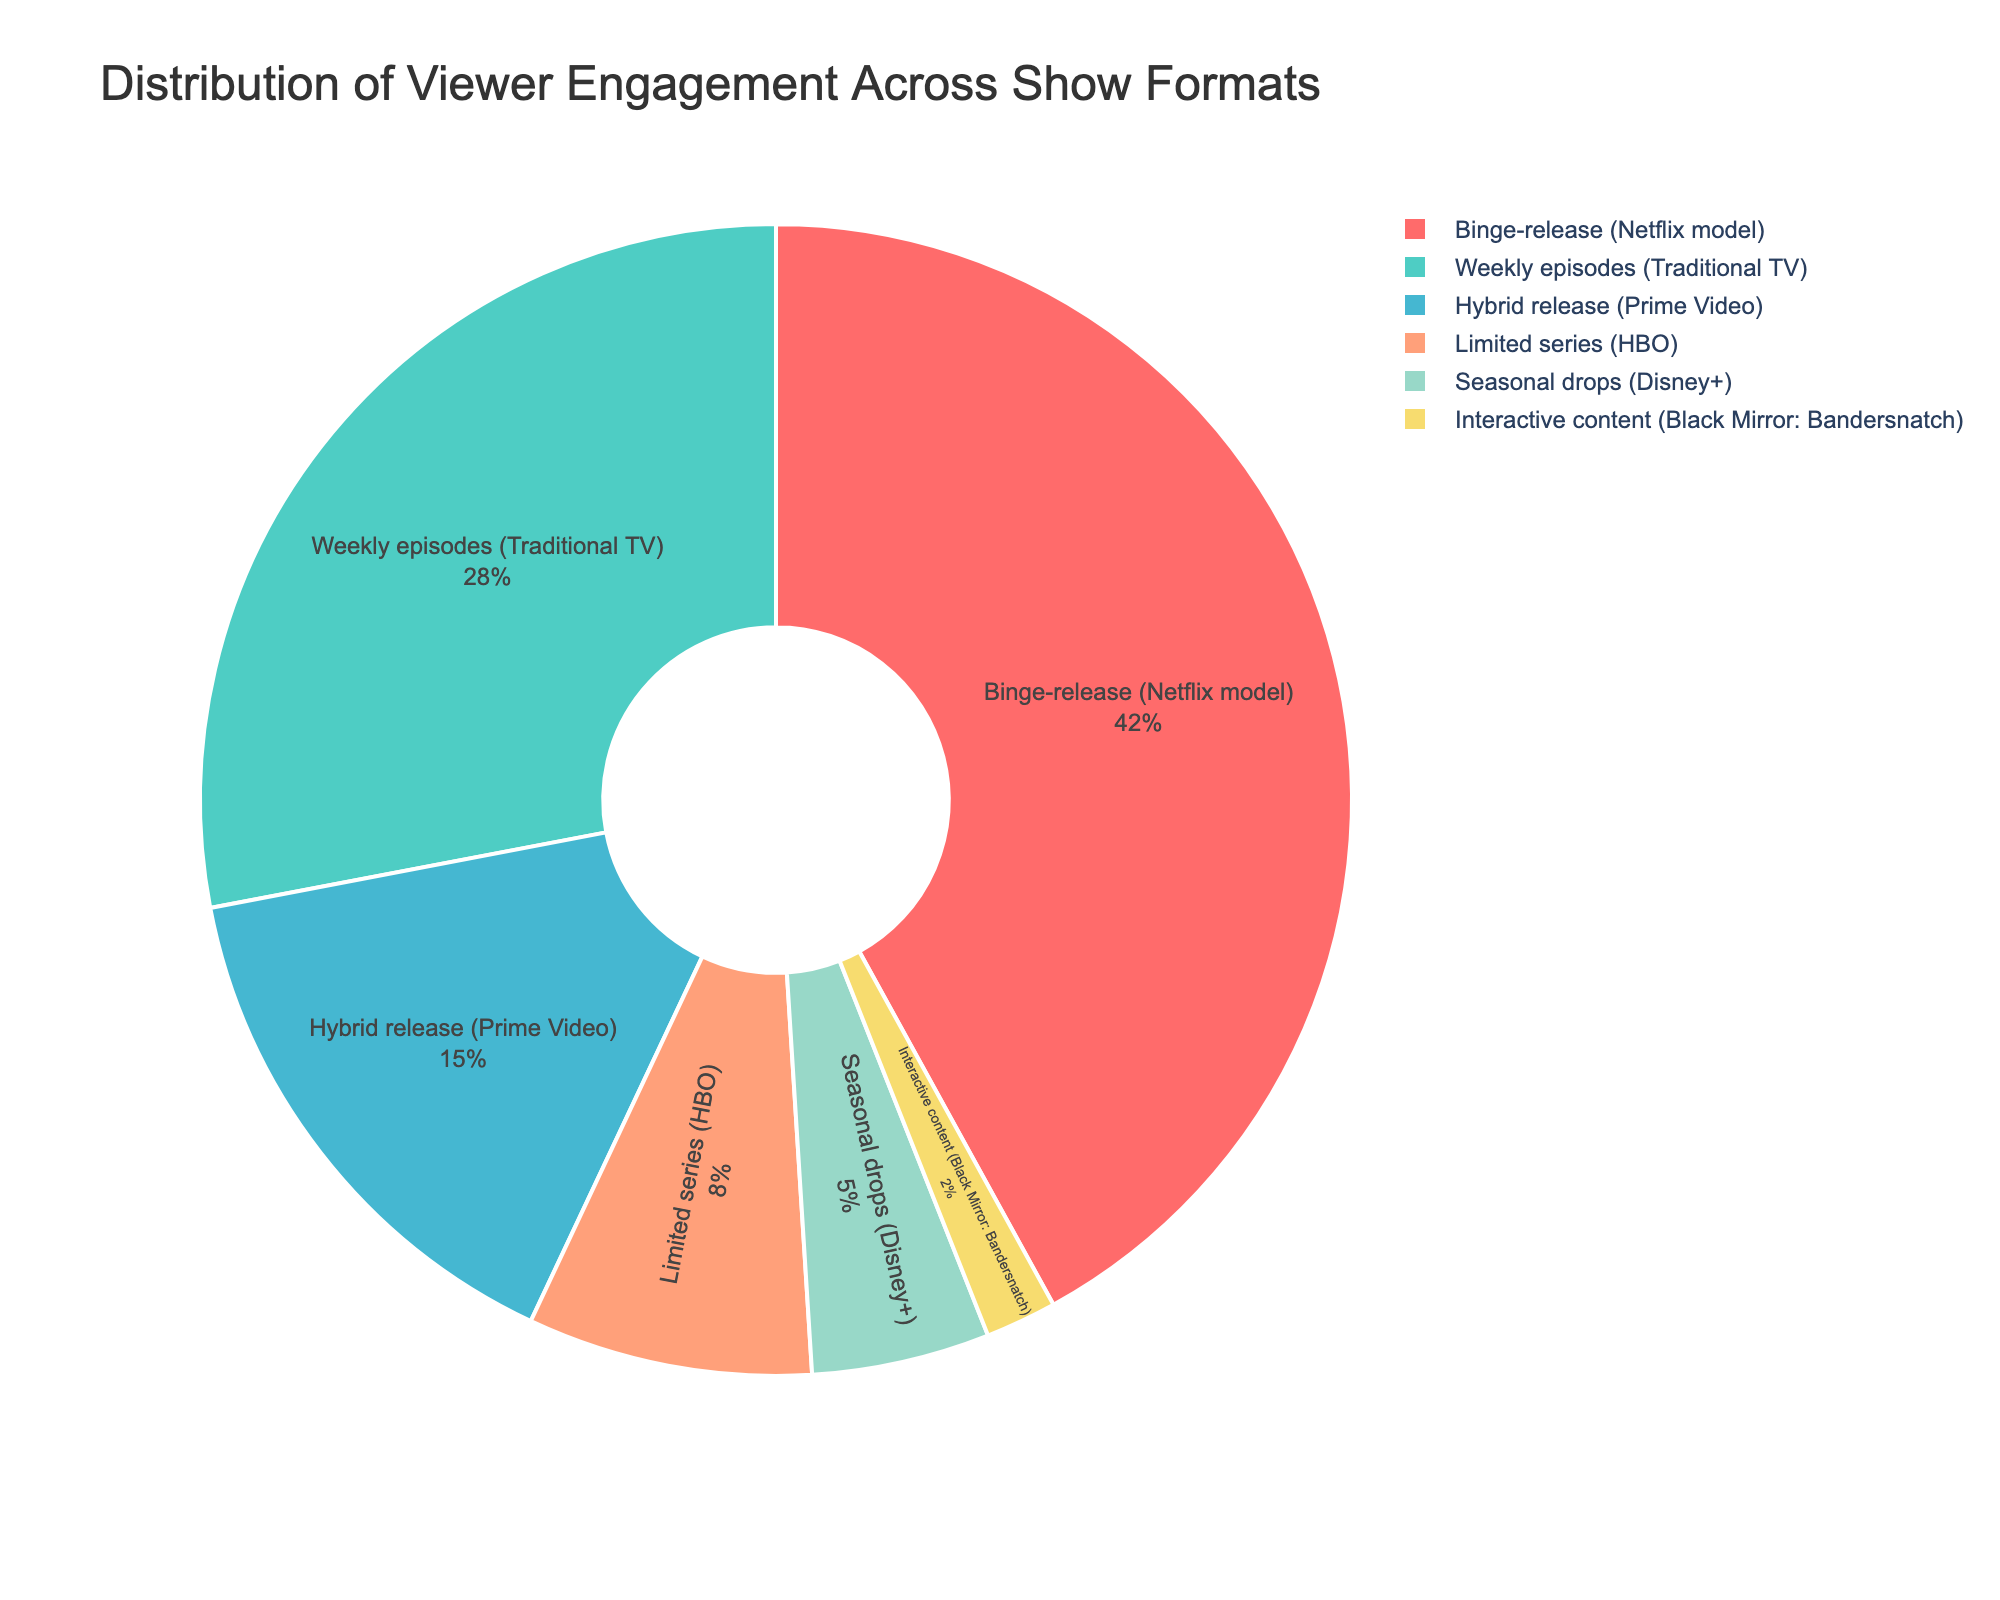What's the show format with the highest viewer engagement? The segment representing "Binge-release (Netflix model)" is the largest slice of the pie chart.
Answer: Binge-release (Netflix model) How much higher is the viewer engagement percentage for binge-release compared to weekly episodes? The viewer engagement for binge-release is 42%, while it's 28% for weekly episodes. The difference is calculated as 42% - 28% = 14%.
Answer: 14% What is the combined viewer engagement percentage for hybrid release and limited series? The viewer engagement for hybrid release is 15%, and for limited series, it's 8%. The combined engagement is calculated as 15% + 8% = 23%.
Answer: 23% Which show format has the least viewer engagement? The smallest slice of the pie chart corresponds to "Interactive content (Black Mirror: Bandersnatch)" with 2%.
Answer: Interactive content (Black Mirror: Bandersnatch) What is the average viewer engagement percentage across all show formats? Summing the percentages for all formats gives 42% + 28% + 15% + 8% + 5% + 2% = 100%. There are 6 formats, so the average is 100% / 6 ≈ 16.67%.
Answer: 16.67% Is the viewer engagement for seasonal drops more or less than half of the engagement for weekly episodes? The engagement for seasonal drops (5%) is less than half of the engagement for weekly episodes (28% / 2 = 14%).
Answer: Less What percentage of viewer engagement is captured by show formats other than binge-release and weekly episodes? Combining the percentages of hybrid release, limited series, seasonal drops, and interactive content: 15% + 8% + 5% + 2% = 30%.
Answer: 30% Which color in the pie chart represents the show format with the second-highest viewer engagement? The second-largest slice corresponds to "Weekly episodes (Traditional TV)" which is depicted in green.
Answer: Green Between hybrid release and limited series, which has a higher viewer engagement percentage and by how much? Hybrid release has a higher engagement of 15% compared to limited series with 8%. The difference is 15% - 8% = 7%.
Answer: Hybrid release by 7% How does the engagement of the least engaging format compare to the most engaging format? The least engaging format is interactive content with 2%, while the most engaging is binge-release with 42%. Comparing the two, 42% / 2% = 21 times higher.
Answer: 21 times higher 